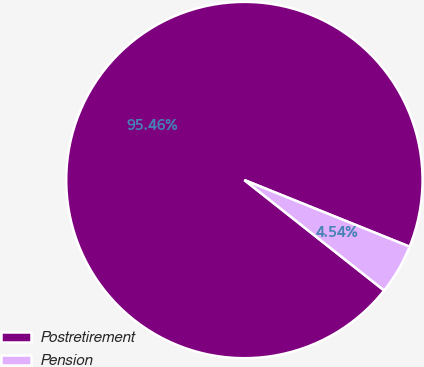Convert chart to OTSL. <chart><loc_0><loc_0><loc_500><loc_500><pie_chart><fcel>Postretirement<fcel>Pension<nl><fcel>95.46%<fcel>4.54%<nl></chart> 